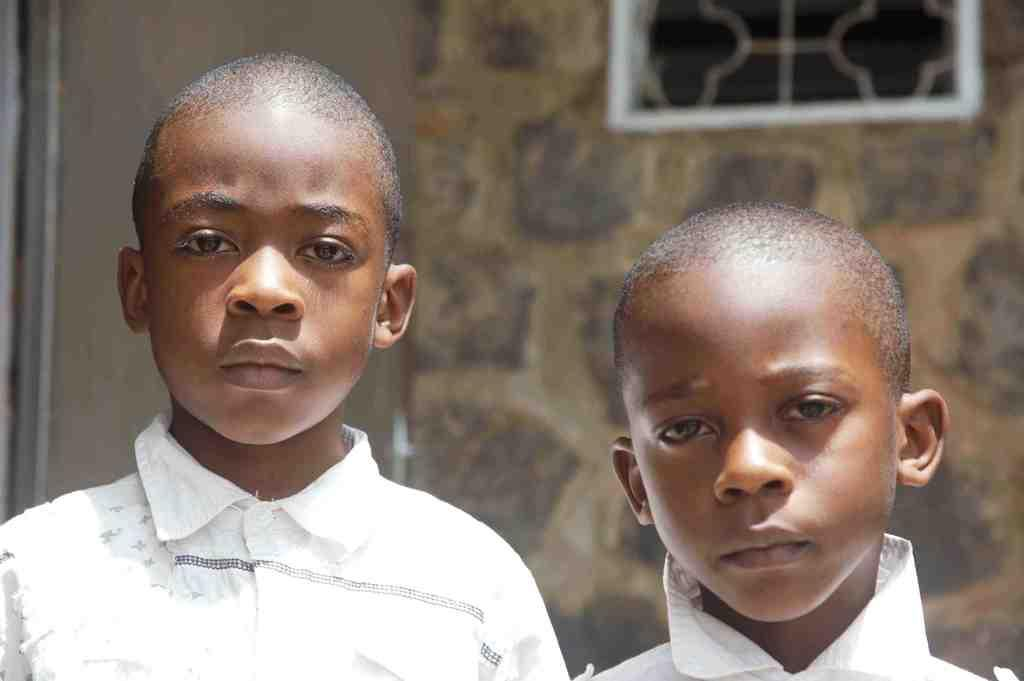How many children are present in the image? There are two children in the image. What can be seen in the background of the image? There is a window and a wall in the background of the image. What type of cloud can be seen in the image? There is no cloud visible in the image; only a window and a wall are present in the background. 